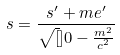<formula> <loc_0><loc_0><loc_500><loc_500>s = \frac { s ^ { \prime } + m e ^ { \prime } } { \sqrt { [ } ] { 0 - \frac { m ^ { 2 } } { c ^ { 2 } } } }</formula> 